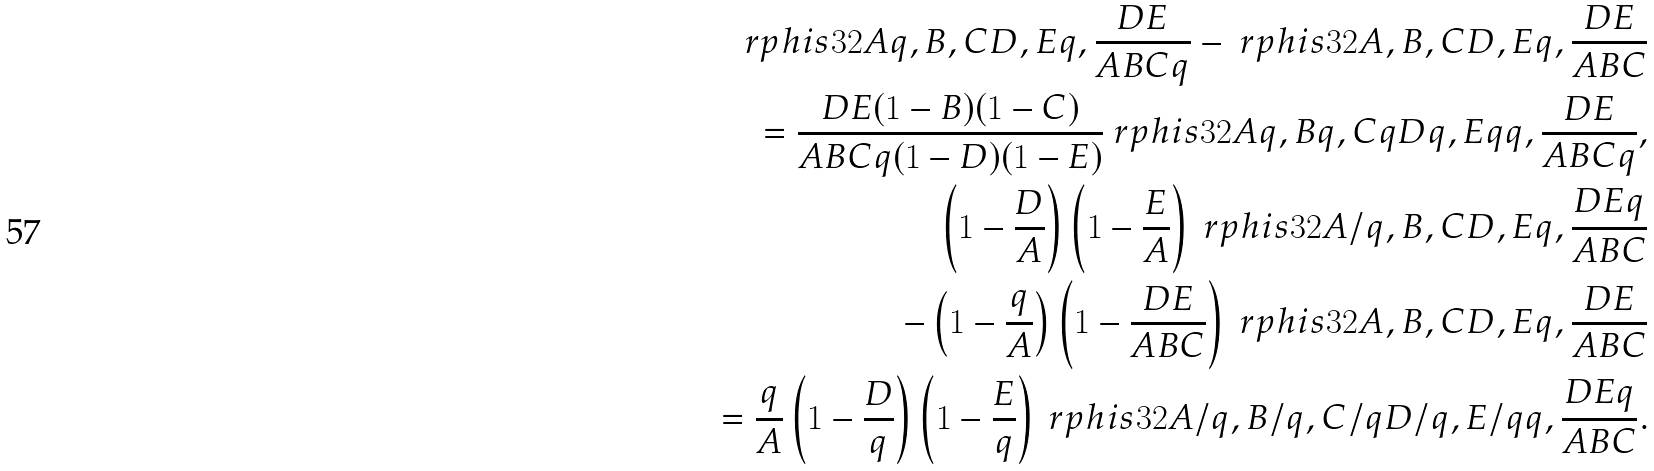Convert formula to latex. <formula><loc_0><loc_0><loc_500><loc_500>\ r p h i s { 3 } { 2 } { A q , B , C } { D , E } { q , \frac { D E } { A B C q } } - \ r p h i s { 3 } { 2 } { A , B , C } { D , E } { q , \frac { D E } { A B C } } \\ = \frac { D E ( 1 - B ) ( 1 - C ) } { A B C q ( 1 - D ) ( 1 - E ) } \ r p h i s { 3 } { 2 } { A q , B q , C q } { D q , E q } { q , \frac { D E } { A B C q } } , \\ \left ( 1 - \frac { D } { A } \right ) \left ( 1 - \frac { E } { A } \right ) \ r p h i s { 3 } { 2 } { A / q , B , C } { D , E } { q , \frac { D E q } { A B C } } \\ - \left ( 1 - \frac { q } { A } \right ) \left ( 1 - \frac { D E } { A B C } \right ) \ r p h i s { 3 } { 2 } { A , B , C } { D , E } { q , \frac { D E } { A B C } } \\ = \frac { q } { A } \left ( 1 - \frac { D } { q } \right ) \left ( 1 - \frac { E } { q } \right ) \ r p h i s { 3 } { 2 } { A / q , B / q , C / q } { D / q , E / q } { q , \frac { D E q } { A B C } } .</formula> 